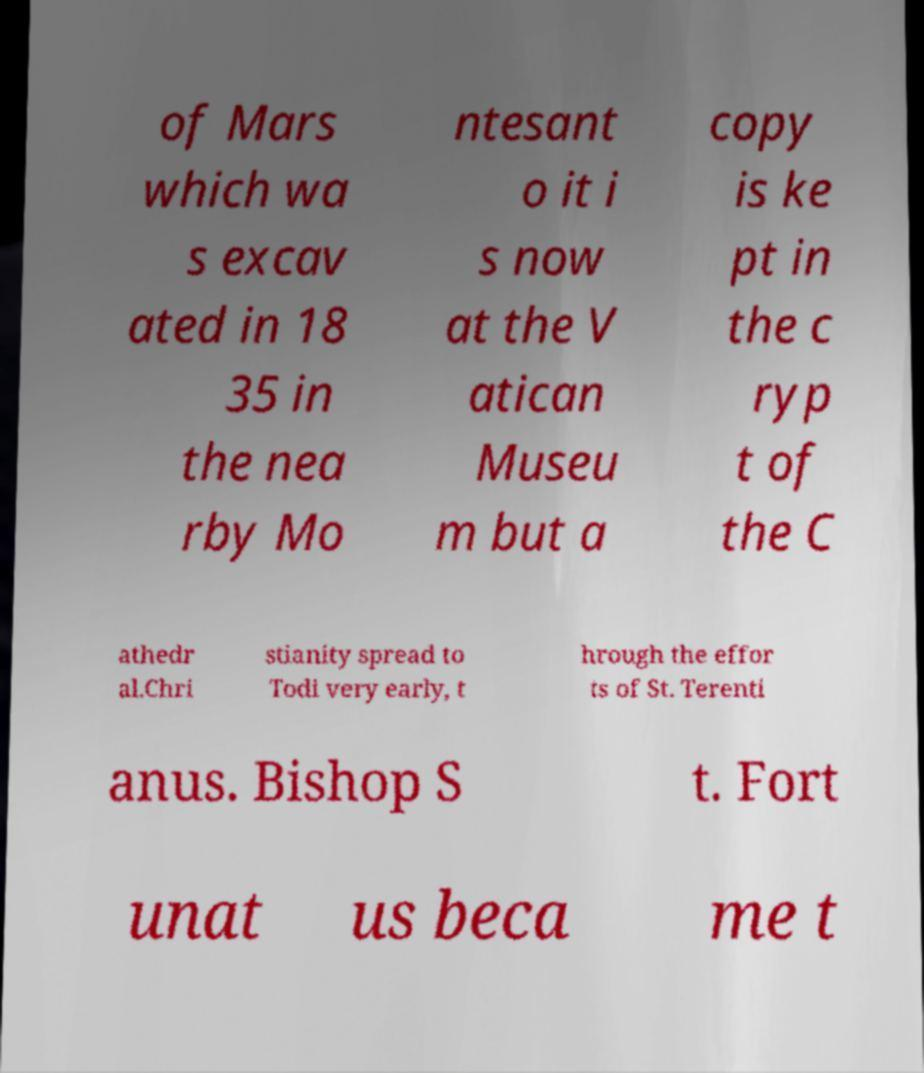What messages or text are displayed in this image? I need them in a readable, typed format. of Mars which wa s excav ated in 18 35 in the nea rby Mo ntesant o it i s now at the V atican Museu m but a copy is ke pt in the c ryp t of the C athedr al.Chri stianity spread to Todi very early, t hrough the effor ts of St. Terenti anus. Bishop S t. Fort unat us beca me t 